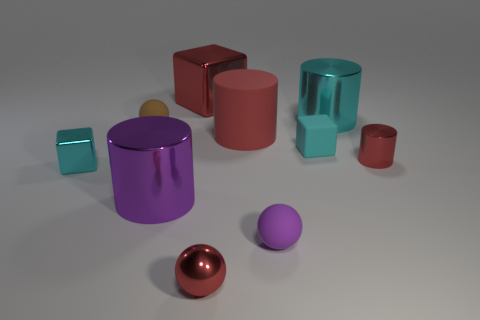Subtract all small cyan blocks. How many blocks are left? 1 Subtract all cyan cubes. How many cubes are left? 1 Subtract all green cylinders. How many cyan blocks are left? 2 Add 4 small purple matte objects. How many small purple matte objects are left? 5 Add 5 balls. How many balls exist? 8 Subtract 0 yellow cylinders. How many objects are left? 10 Subtract all cylinders. How many objects are left? 6 Subtract 3 cylinders. How many cylinders are left? 1 Subtract all red cylinders. Subtract all cyan balls. How many cylinders are left? 2 Subtract all small cyan matte objects. Subtract all small red metallic balls. How many objects are left? 8 